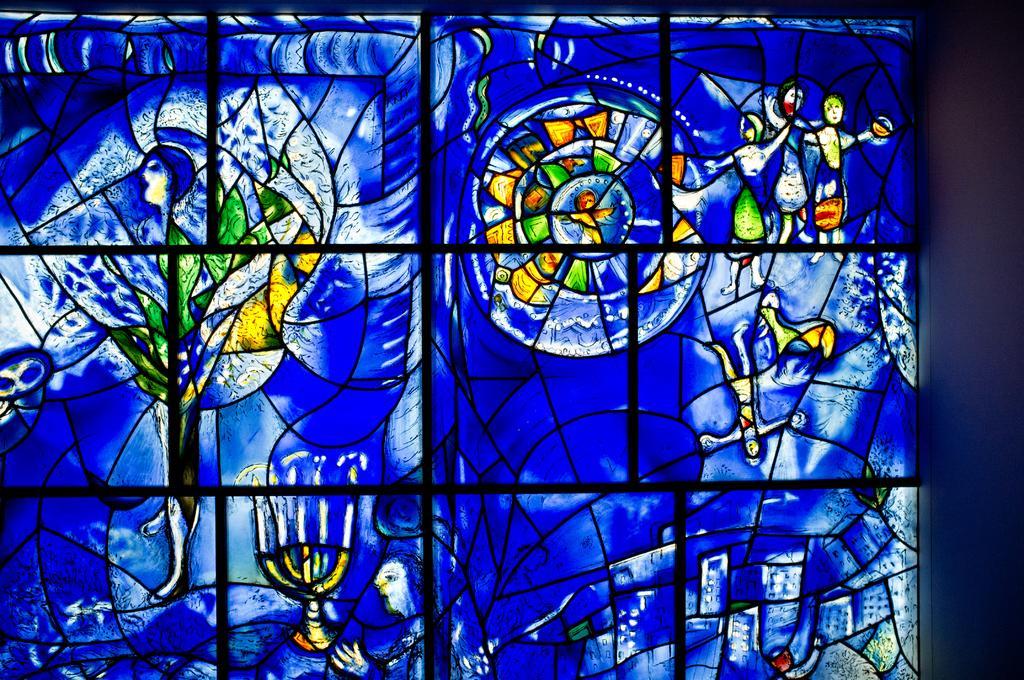Can you describe this image briefly? In the center of this picture we can see a blue color object on which we can see the pictures of persons and the pictures of many other objects. On the right corner there is another object. 